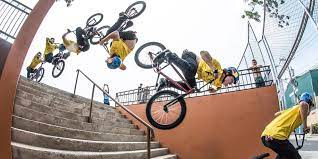How many bicycles would there be in the image if someone has deleted two bicycles from the picture? Originally, there are four bicycles captured at different stages of a stunt sequence by a single cyclist in the image. If we imagine digitally removing two of these bicycles, we'd be left with two bicycles, completing the visualization of this adrenaline-pumping moment in a more sparse yet still dynamic way. 